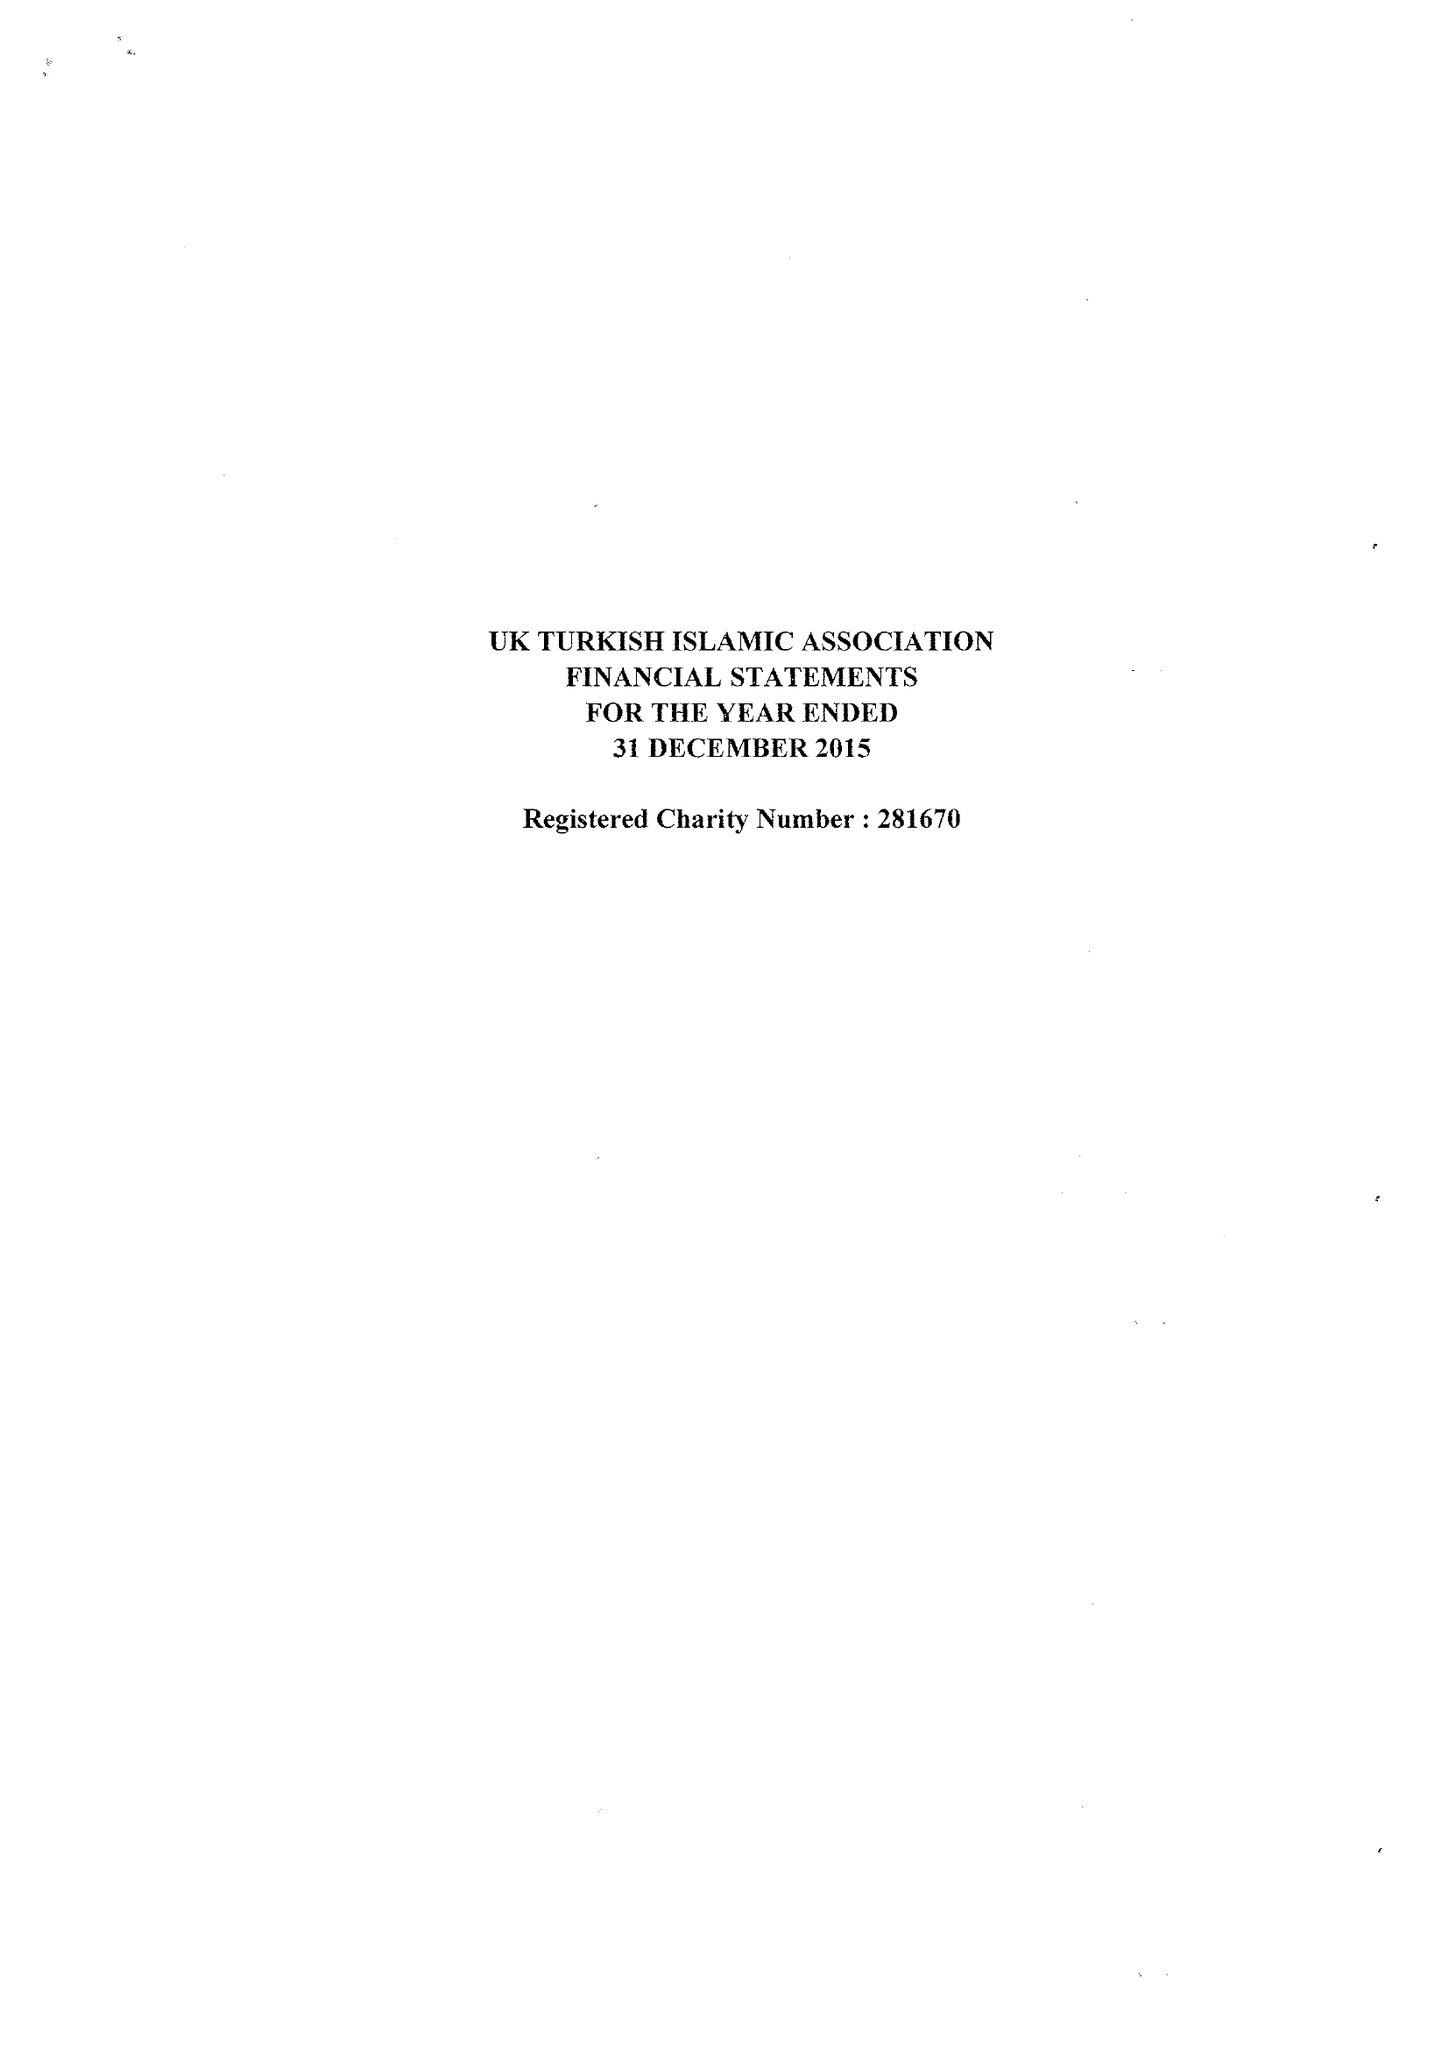What is the value for the address__street_line?
Answer the question using a single word or phrase. None 